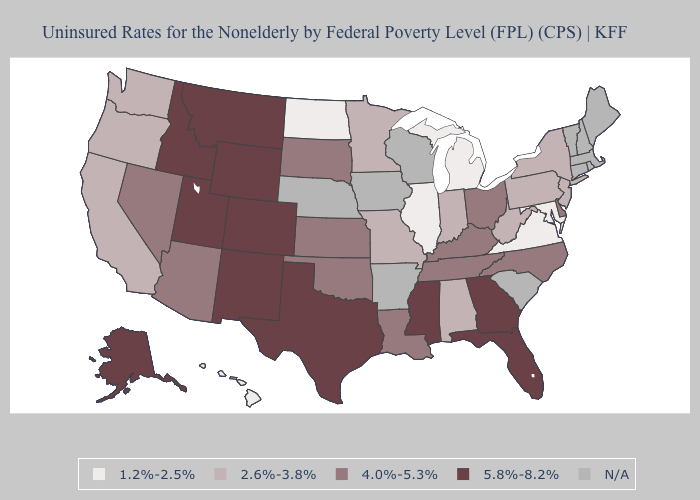Which states have the lowest value in the West?
Answer briefly. Hawaii. Name the states that have a value in the range 2.6%-3.8%?
Concise answer only. Alabama, California, Indiana, Minnesota, Missouri, New Jersey, New York, Oregon, Pennsylvania, Washington, West Virginia. Name the states that have a value in the range 4.0%-5.3%?
Keep it brief. Arizona, Delaware, Kansas, Kentucky, Louisiana, Nevada, North Carolina, Ohio, Oklahoma, South Dakota, Tennessee. Name the states that have a value in the range 1.2%-2.5%?
Write a very short answer. Hawaii, Illinois, Maryland, Michigan, North Dakota, Virginia. Name the states that have a value in the range N/A?
Write a very short answer. Arkansas, Connecticut, Iowa, Maine, Massachusetts, Nebraska, New Hampshire, Rhode Island, South Carolina, Vermont, Wisconsin. Name the states that have a value in the range N/A?
Short answer required. Arkansas, Connecticut, Iowa, Maine, Massachusetts, Nebraska, New Hampshire, Rhode Island, South Carolina, Vermont, Wisconsin. Name the states that have a value in the range 5.8%-8.2%?
Keep it brief. Alaska, Colorado, Florida, Georgia, Idaho, Mississippi, Montana, New Mexico, Texas, Utah, Wyoming. Does the map have missing data?
Quick response, please. Yes. How many symbols are there in the legend?
Give a very brief answer. 5. Name the states that have a value in the range 2.6%-3.8%?
Write a very short answer. Alabama, California, Indiana, Minnesota, Missouri, New Jersey, New York, Oregon, Pennsylvania, Washington, West Virginia. What is the value of Delaware?
Give a very brief answer. 4.0%-5.3%. Does Kansas have the highest value in the MidWest?
Be succinct. Yes. How many symbols are there in the legend?
Answer briefly. 5. Name the states that have a value in the range 1.2%-2.5%?
Keep it brief. Hawaii, Illinois, Maryland, Michigan, North Dakota, Virginia. 